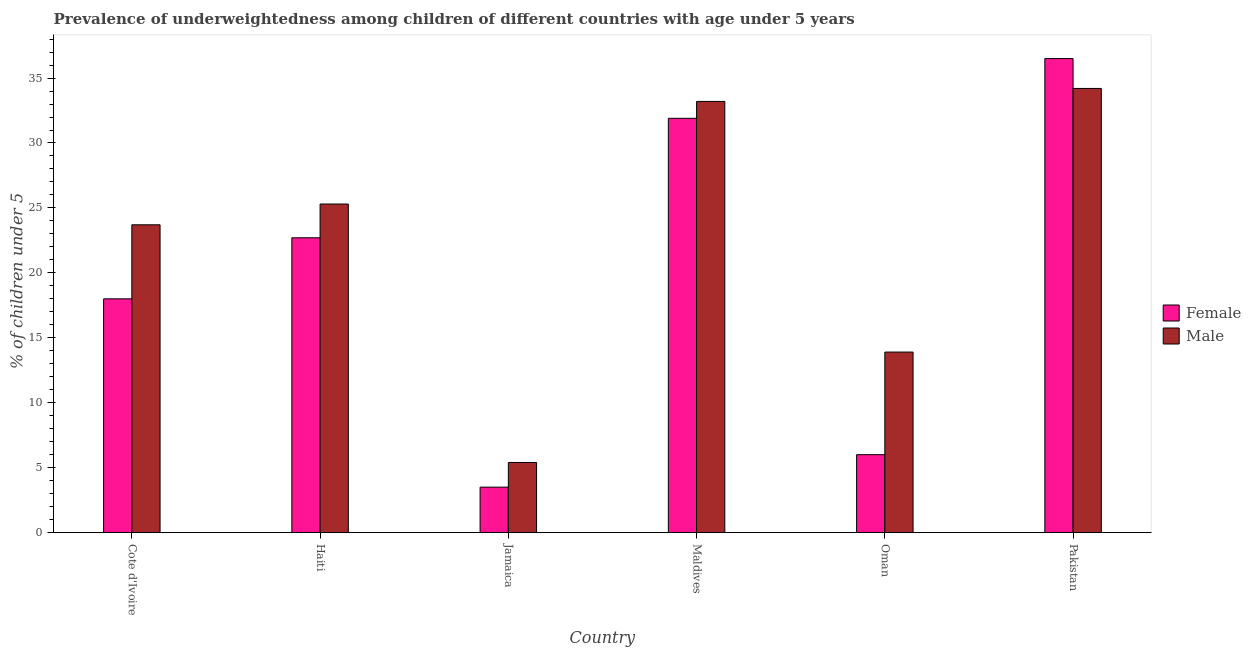How many groups of bars are there?
Offer a terse response. 6. Are the number of bars per tick equal to the number of legend labels?
Your response must be concise. Yes. How many bars are there on the 4th tick from the left?
Offer a very short reply. 2. What is the label of the 1st group of bars from the left?
Your response must be concise. Cote d'Ivoire. What is the percentage of underweighted female children in Maldives?
Your answer should be compact. 31.9. Across all countries, what is the maximum percentage of underweighted female children?
Make the answer very short. 36.5. Across all countries, what is the minimum percentage of underweighted male children?
Your answer should be compact. 5.4. In which country was the percentage of underweighted female children maximum?
Provide a succinct answer. Pakistan. In which country was the percentage of underweighted male children minimum?
Your answer should be very brief. Jamaica. What is the total percentage of underweighted male children in the graph?
Offer a terse response. 135.7. What is the difference between the percentage of underweighted male children in Cote d'Ivoire and that in Jamaica?
Provide a short and direct response. 18.3. What is the difference between the percentage of underweighted male children in Pakistan and the percentage of underweighted female children in Jamaica?
Your answer should be compact. 30.7. What is the average percentage of underweighted male children per country?
Give a very brief answer. 22.62. What is the difference between the percentage of underweighted female children and percentage of underweighted male children in Oman?
Make the answer very short. -7.9. In how many countries, is the percentage of underweighted female children greater than 26 %?
Provide a succinct answer. 2. What is the ratio of the percentage of underweighted female children in Cote d'Ivoire to that in Pakistan?
Provide a succinct answer. 0.49. Is the percentage of underweighted female children in Haiti less than that in Jamaica?
Make the answer very short. No. What is the difference between the highest and the second highest percentage of underweighted male children?
Offer a very short reply. 1. What is the difference between the highest and the lowest percentage of underweighted female children?
Provide a succinct answer. 33. What does the 2nd bar from the right in Haiti represents?
Ensure brevity in your answer.  Female. How many bars are there?
Your response must be concise. 12. Are all the bars in the graph horizontal?
Keep it short and to the point. No. How many countries are there in the graph?
Ensure brevity in your answer.  6. What is the difference between two consecutive major ticks on the Y-axis?
Provide a short and direct response. 5. Does the graph contain any zero values?
Your answer should be very brief. No. Does the graph contain grids?
Your answer should be compact. No. Where does the legend appear in the graph?
Make the answer very short. Center right. How are the legend labels stacked?
Your answer should be compact. Vertical. What is the title of the graph?
Provide a succinct answer. Prevalence of underweightedness among children of different countries with age under 5 years. What is the label or title of the Y-axis?
Give a very brief answer.  % of children under 5. What is the  % of children under 5 of Female in Cote d'Ivoire?
Your response must be concise. 18. What is the  % of children under 5 in Male in Cote d'Ivoire?
Give a very brief answer. 23.7. What is the  % of children under 5 in Female in Haiti?
Offer a terse response. 22.7. What is the  % of children under 5 of Male in Haiti?
Offer a very short reply. 25.3. What is the  % of children under 5 of Male in Jamaica?
Your answer should be very brief. 5.4. What is the  % of children under 5 of Female in Maldives?
Your response must be concise. 31.9. What is the  % of children under 5 in Male in Maldives?
Make the answer very short. 33.2. What is the  % of children under 5 in Male in Oman?
Your response must be concise. 13.9. What is the  % of children under 5 in Female in Pakistan?
Offer a very short reply. 36.5. What is the  % of children under 5 in Male in Pakistan?
Your answer should be very brief. 34.2. Across all countries, what is the maximum  % of children under 5 of Female?
Your response must be concise. 36.5. Across all countries, what is the maximum  % of children under 5 in Male?
Your answer should be compact. 34.2. Across all countries, what is the minimum  % of children under 5 of Male?
Offer a terse response. 5.4. What is the total  % of children under 5 of Female in the graph?
Provide a short and direct response. 118.6. What is the total  % of children under 5 of Male in the graph?
Provide a succinct answer. 135.7. What is the difference between the  % of children under 5 of Female in Cote d'Ivoire and that in Haiti?
Make the answer very short. -4.7. What is the difference between the  % of children under 5 of Female in Cote d'Ivoire and that in Jamaica?
Offer a terse response. 14.5. What is the difference between the  % of children under 5 of Female in Cote d'Ivoire and that in Maldives?
Offer a terse response. -13.9. What is the difference between the  % of children under 5 of Female in Cote d'Ivoire and that in Oman?
Your answer should be very brief. 12. What is the difference between the  % of children under 5 in Male in Cote d'Ivoire and that in Oman?
Ensure brevity in your answer.  9.8. What is the difference between the  % of children under 5 of Female in Cote d'Ivoire and that in Pakistan?
Provide a succinct answer. -18.5. What is the difference between the  % of children under 5 of Female in Haiti and that in Jamaica?
Keep it short and to the point. 19.2. What is the difference between the  % of children under 5 in Female in Haiti and that in Oman?
Provide a succinct answer. 16.7. What is the difference between the  % of children under 5 of Male in Haiti and that in Oman?
Your answer should be compact. 11.4. What is the difference between the  % of children under 5 in Female in Jamaica and that in Maldives?
Your answer should be compact. -28.4. What is the difference between the  % of children under 5 of Male in Jamaica and that in Maldives?
Your response must be concise. -27.8. What is the difference between the  % of children under 5 in Female in Jamaica and that in Oman?
Give a very brief answer. -2.5. What is the difference between the  % of children under 5 of Male in Jamaica and that in Oman?
Keep it short and to the point. -8.5. What is the difference between the  % of children under 5 of Female in Jamaica and that in Pakistan?
Offer a terse response. -33. What is the difference between the  % of children under 5 in Male in Jamaica and that in Pakistan?
Ensure brevity in your answer.  -28.8. What is the difference between the  % of children under 5 in Female in Maldives and that in Oman?
Provide a succinct answer. 25.9. What is the difference between the  % of children under 5 in Male in Maldives and that in Oman?
Your answer should be very brief. 19.3. What is the difference between the  % of children under 5 of Female in Maldives and that in Pakistan?
Make the answer very short. -4.6. What is the difference between the  % of children under 5 of Female in Oman and that in Pakistan?
Give a very brief answer. -30.5. What is the difference between the  % of children under 5 of Male in Oman and that in Pakistan?
Keep it short and to the point. -20.3. What is the difference between the  % of children under 5 in Female in Cote d'Ivoire and the  % of children under 5 in Male in Jamaica?
Ensure brevity in your answer.  12.6. What is the difference between the  % of children under 5 in Female in Cote d'Ivoire and the  % of children under 5 in Male in Maldives?
Give a very brief answer. -15.2. What is the difference between the  % of children under 5 in Female in Cote d'Ivoire and the  % of children under 5 in Male in Pakistan?
Provide a succinct answer. -16.2. What is the difference between the  % of children under 5 of Female in Haiti and the  % of children under 5 of Male in Oman?
Offer a very short reply. 8.8. What is the difference between the  % of children under 5 of Female in Jamaica and the  % of children under 5 of Male in Maldives?
Provide a succinct answer. -29.7. What is the difference between the  % of children under 5 in Female in Jamaica and the  % of children under 5 in Male in Oman?
Provide a short and direct response. -10.4. What is the difference between the  % of children under 5 of Female in Jamaica and the  % of children under 5 of Male in Pakistan?
Give a very brief answer. -30.7. What is the difference between the  % of children under 5 of Female in Maldives and the  % of children under 5 of Male in Pakistan?
Your response must be concise. -2.3. What is the difference between the  % of children under 5 of Female in Oman and the  % of children under 5 of Male in Pakistan?
Your answer should be very brief. -28.2. What is the average  % of children under 5 of Female per country?
Give a very brief answer. 19.77. What is the average  % of children under 5 in Male per country?
Your answer should be compact. 22.62. What is the difference between the  % of children under 5 of Female and  % of children under 5 of Male in Haiti?
Provide a short and direct response. -2.6. What is the difference between the  % of children under 5 of Female and  % of children under 5 of Male in Oman?
Give a very brief answer. -7.9. What is the difference between the  % of children under 5 in Female and  % of children under 5 in Male in Pakistan?
Your answer should be very brief. 2.3. What is the ratio of the  % of children under 5 of Female in Cote d'Ivoire to that in Haiti?
Your answer should be very brief. 0.79. What is the ratio of the  % of children under 5 in Male in Cote d'Ivoire to that in Haiti?
Your answer should be compact. 0.94. What is the ratio of the  % of children under 5 of Female in Cote d'Ivoire to that in Jamaica?
Provide a succinct answer. 5.14. What is the ratio of the  % of children under 5 in Male in Cote d'Ivoire to that in Jamaica?
Offer a terse response. 4.39. What is the ratio of the  % of children under 5 of Female in Cote d'Ivoire to that in Maldives?
Your answer should be compact. 0.56. What is the ratio of the  % of children under 5 in Male in Cote d'Ivoire to that in Maldives?
Ensure brevity in your answer.  0.71. What is the ratio of the  % of children under 5 in Female in Cote d'Ivoire to that in Oman?
Ensure brevity in your answer.  3. What is the ratio of the  % of children under 5 of Male in Cote d'Ivoire to that in Oman?
Your answer should be compact. 1.71. What is the ratio of the  % of children under 5 of Female in Cote d'Ivoire to that in Pakistan?
Provide a short and direct response. 0.49. What is the ratio of the  % of children under 5 of Male in Cote d'Ivoire to that in Pakistan?
Offer a very short reply. 0.69. What is the ratio of the  % of children under 5 of Female in Haiti to that in Jamaica?
Give a very brief answer. 6.49. What is the ratio of the  % of children under 5 of Male in Haiti to that in Jamaica?
Your answer should be compact. 4.69. What is the ratio of the  % of children under 5 in Female in Haiti to that in Maldives?
Offer a terse response. 0.71. What is the ratio of the  % of children under 5 of Male in Haiti to that in Maldives?
Make the answer very short. 0.76. What is the ratio of the  % of children under 5 of Female in Haiti to that in Oman?
Ensure brevity in your answer.  3.78. What is the ratio of the  % of children under 5 of Male in Haiti to that in Oman?
Ensure brevity in your answer.  1.82. What is the ratio of the  % of children under 5 of Female in Haiti to that in Pakistan?
Ensure brevity in your answer.  0.62. What is the ratio of the  % of children under 5 of Male in Haiti to that in Pakistan?
Provide a succinct answer. 0.74. What is the ratio of the  % of children under 5 of Female in Jamaica to that in Maldives?
Your answer should be compact. 0.11. What is the ratio of the  % of children under 5 of Male in Jamaica to that in Maldives?
Your answer should be very brief. 0.16. What is the ratio of the  % of children under 5 of Female in Jamaica to that in Oman?
Offer a very short reply. 0.58. What is the ratio of the  % of children under 5 in Male in Jamaica to that in Oman?
Make the answer very short. 0.39. What is the ratio of the  % of children under 5 in Female in Jamaica to that in Pakistan?
Your answer should be compact. 0.1. What is the ratio of the  % of children under 5 in Male in Jamaica to that in Pakistan?
Your answer should be very brief. 0.16. What is the ratio of the  % of children under 5 in Female in Maldives to that in Oman?
Keep it short and to the point. 5.32. What is the ratio of the  % of children under 5 of Male in Maldives to that in Oman?
Keep it short and to the point. 2.39. What is the ratio of the  % of children under 5 in Female in Maldives to that in Pakistan?
Provide a succinct answer. 0.87. What is the ratio of the  % of children under 5 in Male in Maldives to that in Pakistan?
Your response must be concise. 0.97. What is the ratio of the  % of children under 5 of Female in Oman to that in Pakistan?
Give a very brief answer. 0.16. What is the ratio of the  % of children under 5 of Male in Oman to that in Pakistan?
Give a very brief answer. 0.41. What is the difference between the highest and the lowest  % of children under 5 in Male?
Provide a short and direct response. 28.8. 